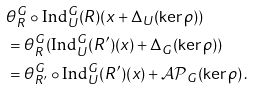<formula> <loc_0><loc_0><loc_500><loc_500>& \theta _ { R } ^ { G } \circ \text {Ind} _ { U } ^ { G } ( R ) ( { x } + \Delta _ { U } ( \ker \rho ) ) \\ & = \theta _ { R } ^ { G } ( \text {Ind} _ { U } ^ { G } ( R ^ { \prime } ) ( { x } ) + \Delta _ { G } ( \ker \rho ) ) \\ & = \theta _ { R ^ { \prime } } ^ { G } \circ \text {Ind} _ { U } ^ { G } ( R ^ { \prime } ) ( { x } ) + { \mathcal { A P } } _ { G } ( \ker \rho ) \, .</formula> 